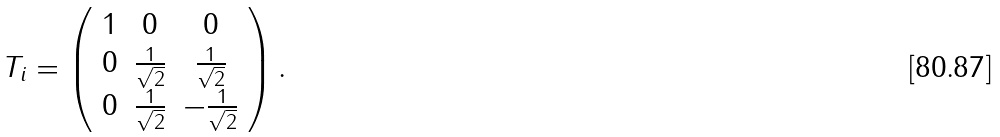Convert formula to latex. <formula><loc_0><loc_0><loc_500><loc_500>T _ { i } = \left ( \begin{array} { c c c } 1 & 0 & 0 \\ 0 & \frac { 1 } { \sqrt { 2 } } & \frac { 1 } { \sqrt { 2 } } \\ 0 & \frac { 1 } { \sqrt { 2 } } & - \frac { 1 } { \sqrt { 2 } } \end{array} \right ) .</formula> 